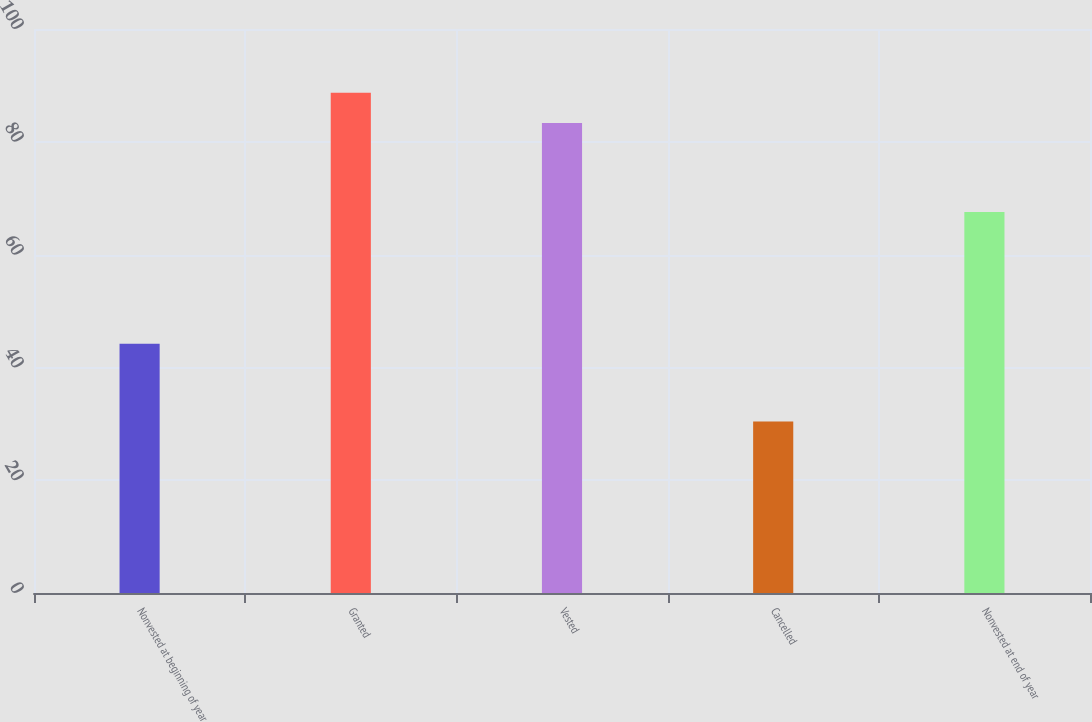Convert chart. <chart><loc_0><loc_0><loc_500><loc_500><bar_chart><fcel>Nonvested at beginning of year<fcel>Granted<fcel>Vested<fcel>Cancelled<fcel>Nonvested at end of year<nl><fcel>44.21<fcel>88.68<fcel>83.34<fcel>30.39<fcel>67.56<nl></chart> 